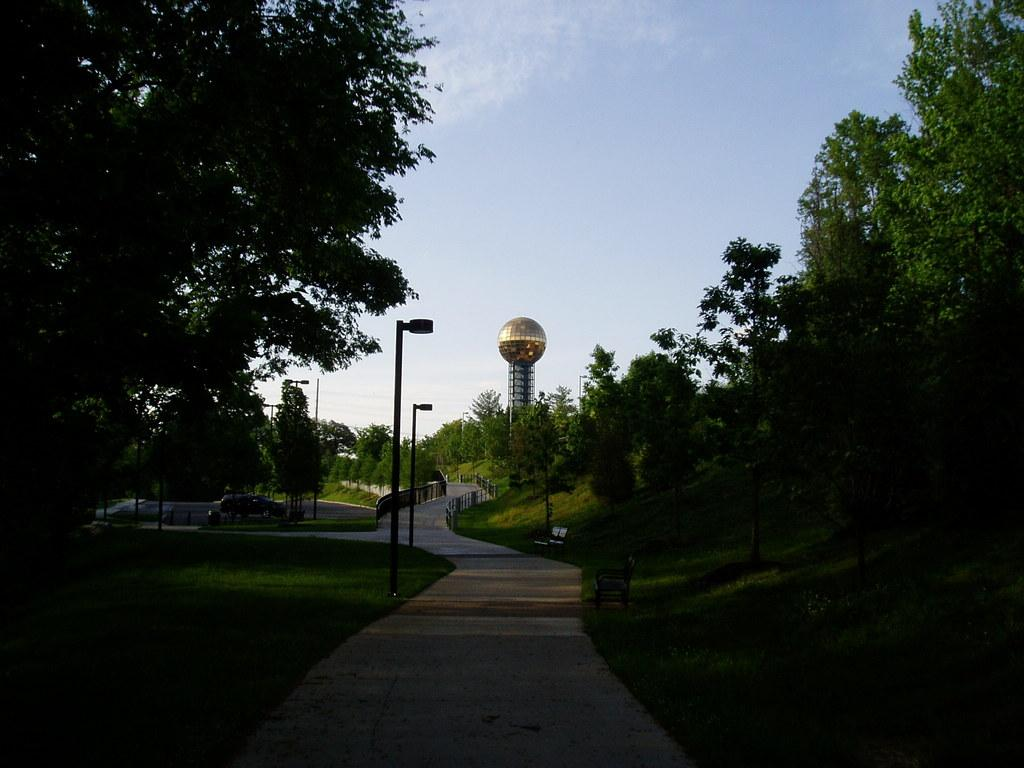What structures or objects are located in the middle of the image? In the middle of the image, there are poles, trees, fencing, and a tower. What type of natural elements can be seen in the middle of the image? In the middle of the image, there are trees. What type of architectural feature is present in the middle of the image? In the middle of the image, there is a tower. What is visible at the top of the image? At the top of the image, there are clouds and the sky. Can you compare the size of the fish in the image to the size of the tower? There are no fish present in the image, so it is not possible to make a comparison. What type of chalk is used to draw on the trees in the image? There is no chalk or drawing activity depicted in the image; it features poles, trees, fencing, and a tower. 